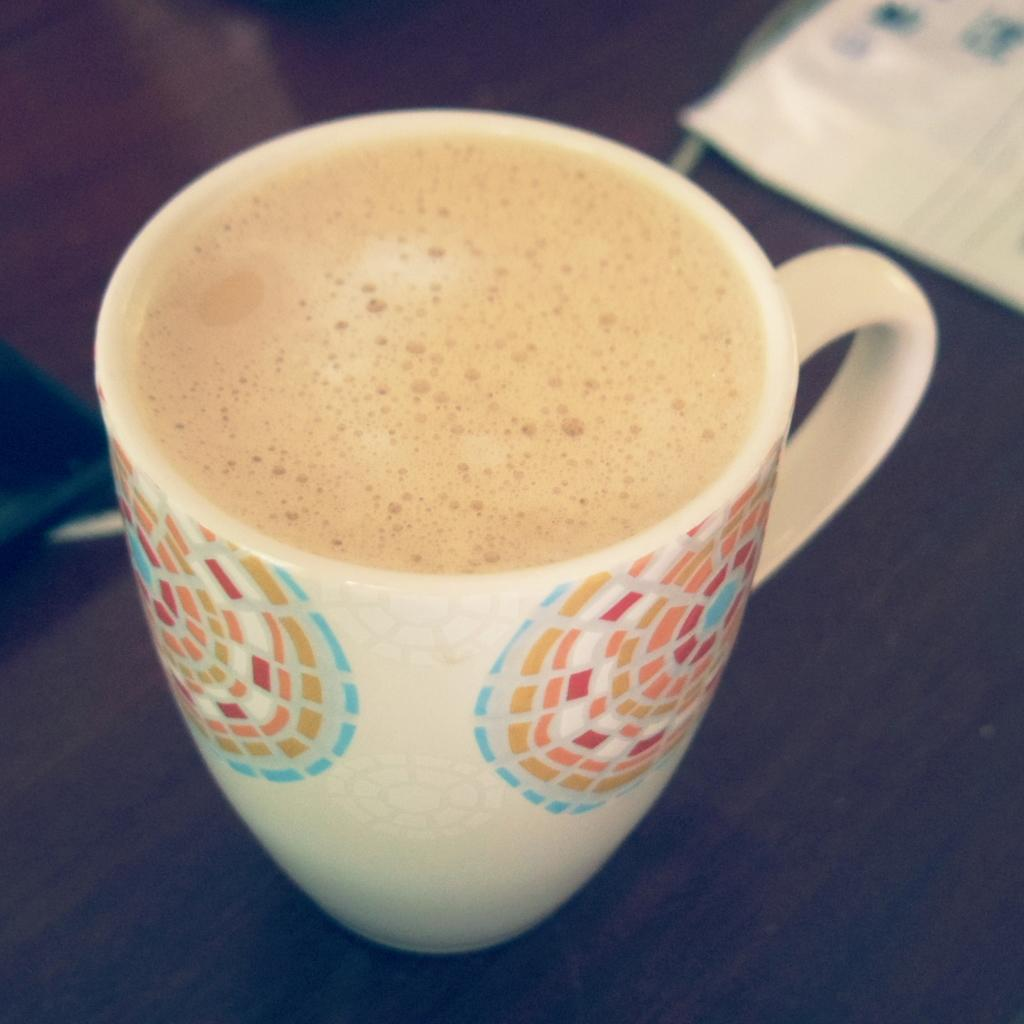What is in the cup that is visible in the image? There is a cup of beverage in the image. Where is the cup of beverage located? The cup of beverage is placed on a table. What type of muscle can be seen flexing in the image? There is no muscle visible in the image; it only features a cup of beverage placed on a table. 